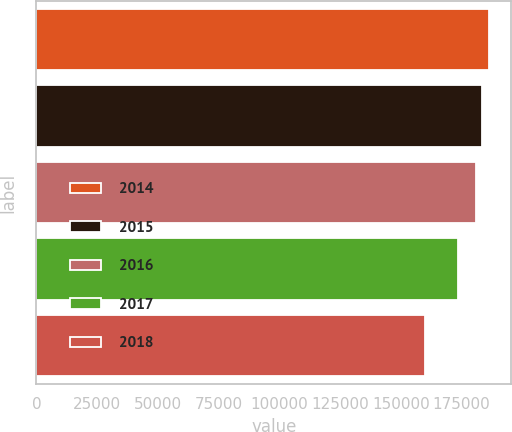<chart> <loc_0><loc_0><loc_500><loc_500><bar_chart><fcel>2014<fcel>2015<fcel>2016<fcel>2017<fcel>2018<nl><fcel>186149<fcel>183654<fcel>181159<fcel>173721<fcel>160152<nl></chart> 